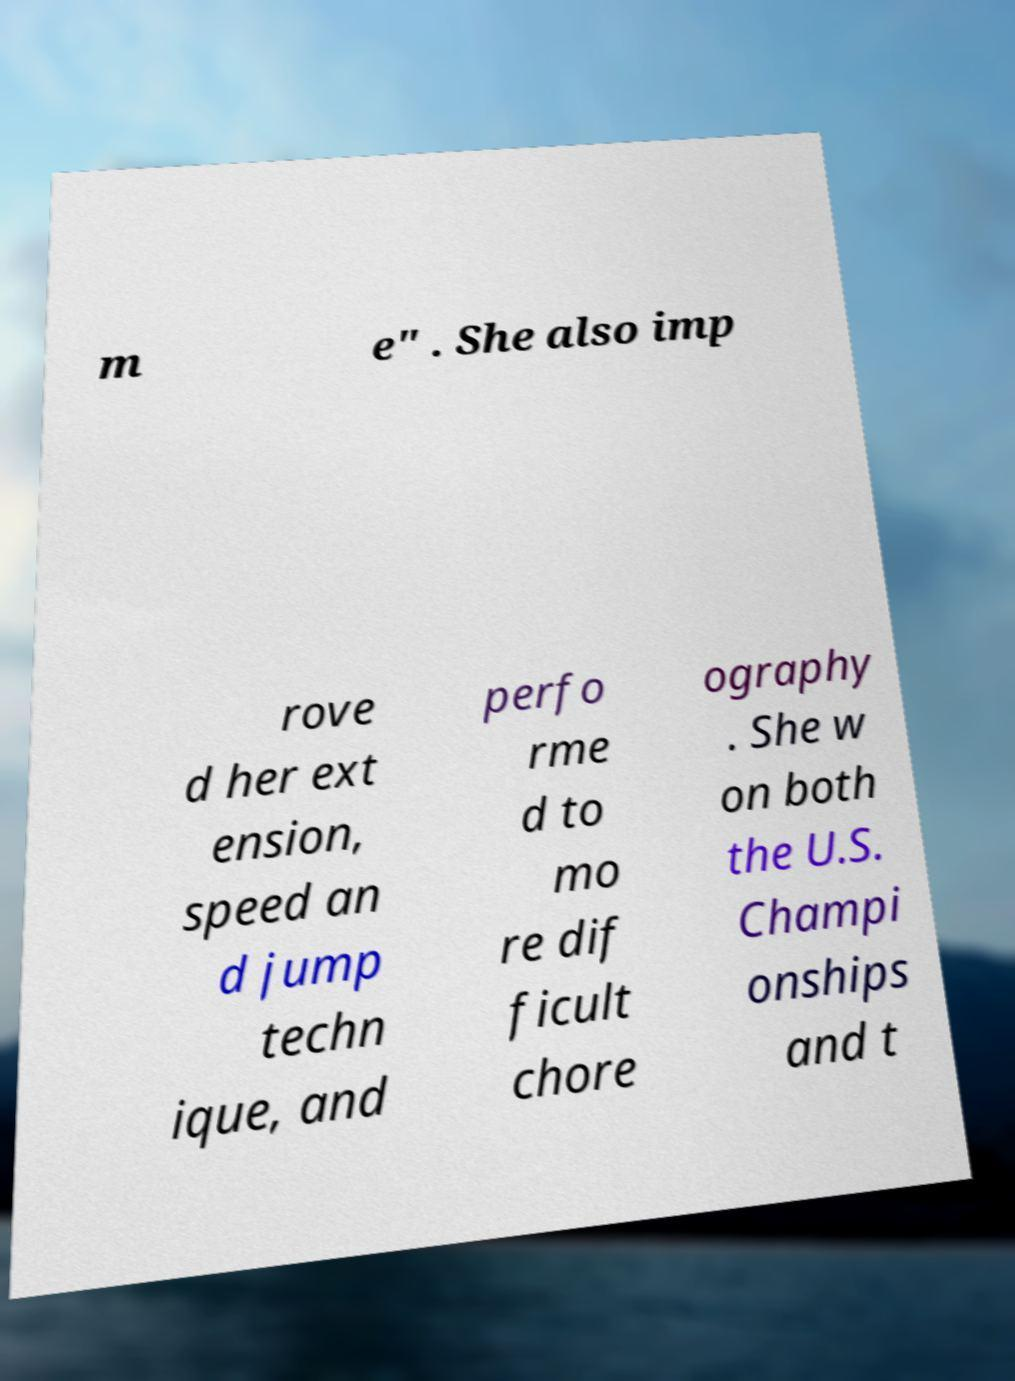What messages or text are displayed in this image? I need them in a readable, typed format. m e" . She also imp rove d her ext ension, speed an d jump techn ique, and perfo rme d to mo re dif ficult chore ography . She w on both the U.S. Champi onships and t 